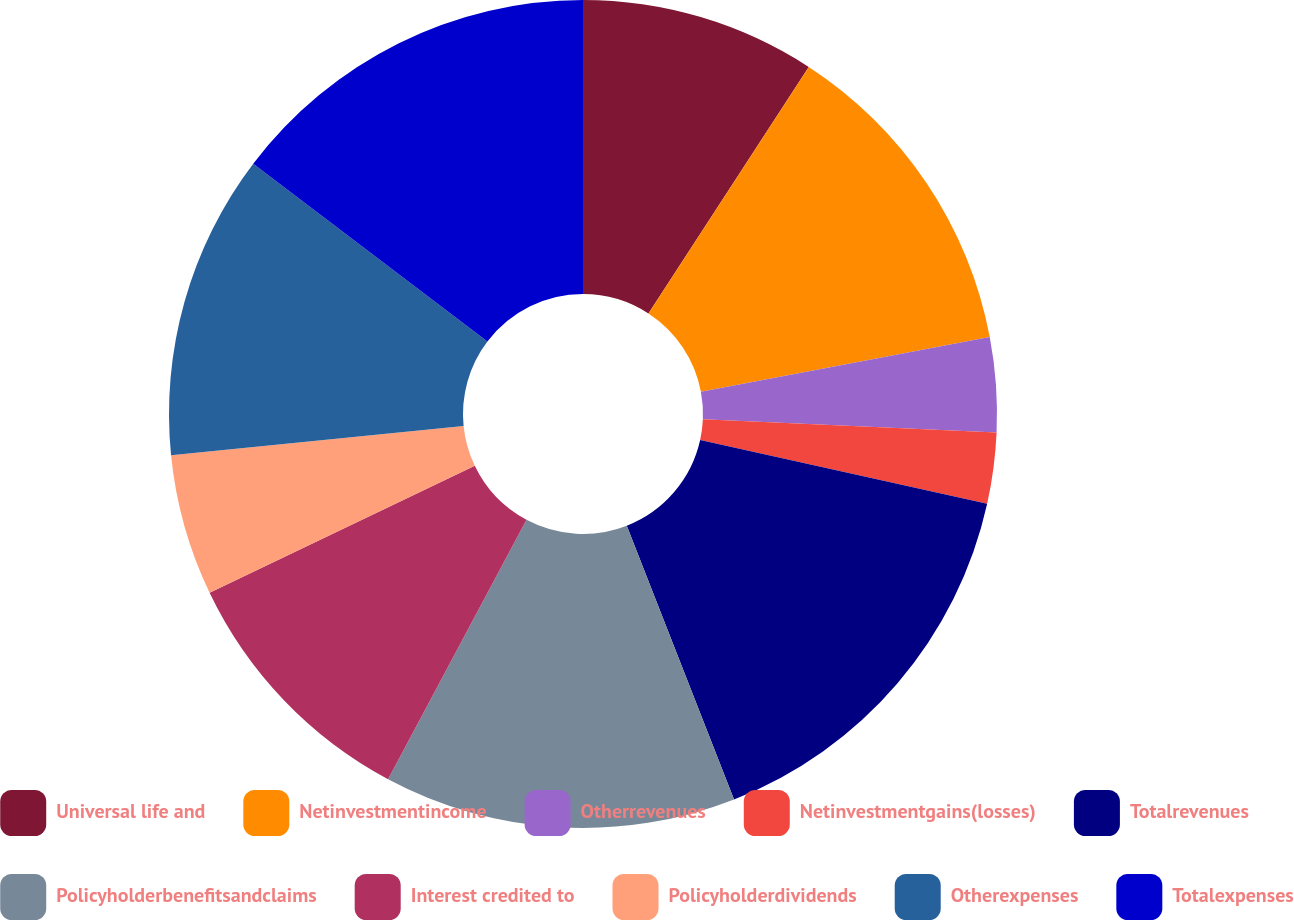Convert chart. <chart><loc_0><loc_0><loc_500><loc_500><pie_chart><fcel>Universal life and<fcel>Netinvestmentincome<fcel>Otherrevenues<fcel>Netinvestmentgains(losses)<fcel>Totalrevenues<fcel>Policyholderbenefitsandclaims<fcel>Interest credited to<fcel>Policyholderdividends<fcel>Otherexpenses<fcel>Totalexpenses<nl><fcel>9.18%<fcel>12.84%<fcel>3.69%<fcel>2.77%<fcel>15.58%<fcel>13.75%<fcel>10.09%<fcel>5.52%<fcel>11.92%<fcel>14.67%<nl></chart> 